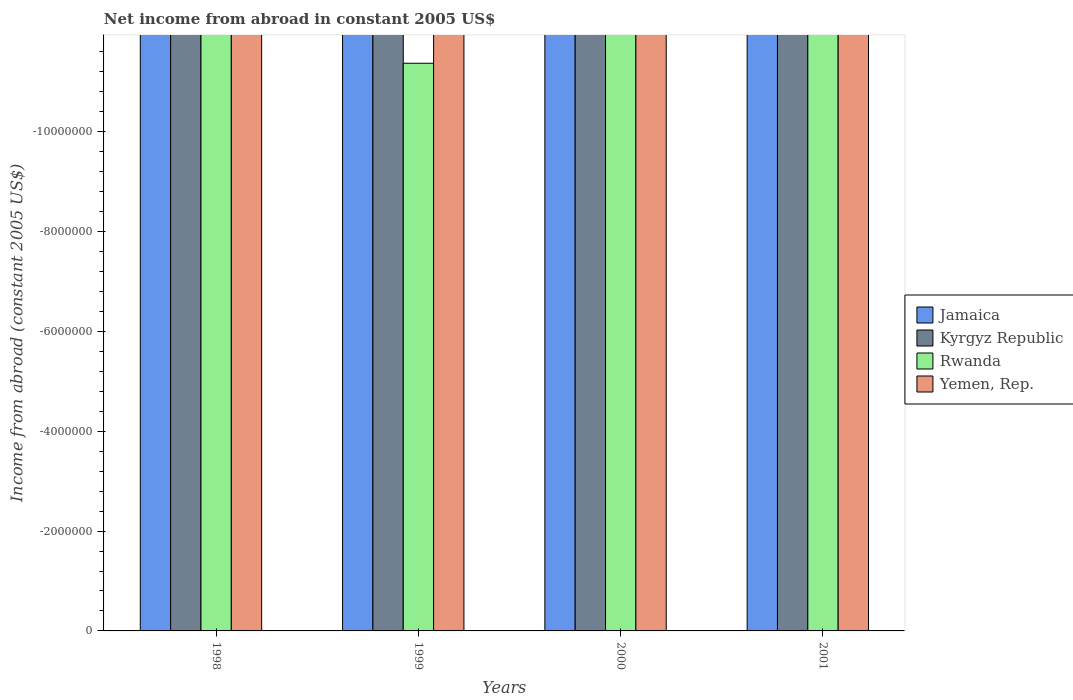What is the net income from abroad in Rwanda in 1998?
Give a very brief answer. 0. Across all years, what is the minimum net income from abroad in Rwanda?
Give a very brief answer. 0. What is the total net income from abroad in Kyrgyz Republic in the graph?
Make the answer very short. 0. What is the difference between the net income from abroad in Kyrgyz Republic in 1998 and the net income from abroad in Rwanda in 2001?
Your answer should be compact. 0. What is the average net income from abroad in Rwanda per year?
Make the answer very short. 0. In how many years, is the net income from abroad in Yemen, Rep. greater than -1200000 US$?
Your answer should be compact. 0. Are all the bars in the graph horizontal?
Offer a very short reply. No. What is the difference between two consecutive major ticks on the Y-axis?
Your answer should be very brief. 2.00e+06. Does the graph contain any zero values?
Ensure brevity in your answer.  Yes. What is the title of the graph?
Your answer should be very brief. Net income from abroad in constant 2005 US$. What is the label or title of the X-axis?
Your answer should be very brief. Years. What is the label or title of the Y-axis?
Make the answer very short. Income from abroad (constant 2005 US$). What is the Income from abroad (constant 2005 US$) in Jamaica in 1998?
Keep it short and to the point. 0. What is the Income from abroad (constant 2005 US$) of Rwanda in 1998?
Offer a very short reply. 0. What is the Income from abroad (constant 2005 US$) of Yemen, Rep. in 1998?
Provide a succinct answer. 0. What is the Income from abroad (constant 2005 US$) of Jamaica in 1999?
Give a very brief answer. 0. What is the Income from abroad (constant 2005 US$) in Yemen, Rep. in 1999?
Your answer should be very brief. 0. What is the Income from abroad (constant 2005 US$) in Kyrgyz Republic in 2000?
Your answer should be compact. 0. What is the Income from abroad (constant 2005 US$) of Rwanda in 2000?
Keep it short and to the point. 0. What is the Income from abroad (constant 2005 US$) in Kyrgyz Republic in 2001?
Keep it short and to the point. 0. What is the Income from abroad (constant 2005 US$) in Yemen, Rep. in 2001?
Keep it short and to the point. 0. What is the total Income from abroad (constant 2005 US$) of Jamaica in the graph?
Provide a succinct answer. 0. What is the total Income from abroad (constant 2005 US$) of Kyrgyz Republic in the graph?
Offer a terse response. 0. What is the total Income from abroad (constant 2005 US$) in Yemen, Rep. in the graph?
Provide a succinct answer. 0. What is the average Income from abroad (constant 2005 US$) of Jamaica per year?
Offer a terse response. 0. What is the average Income from abroad (constant 2005 US$) in Rwanda per year?
Ensure brevity in your answer.  0. 